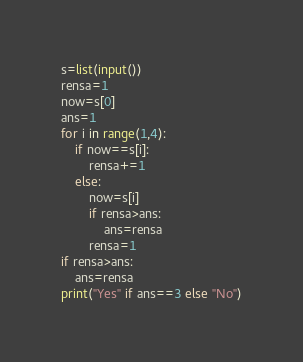<code> <loc_0><loc_0><loc_500><loc_500><_Python_>s=list(input())
rensa=1
now=s[0]
ans=1
for i in range(1,4):
    if now==s[i]:
        rensa+=1
    else:
        now=s[i]
        if rensa>ans:
            ans=rensa
        rensa=1
if rensa>ans:
    ans=rensa 
print("Yes" if ans==3 else "No")</code> 